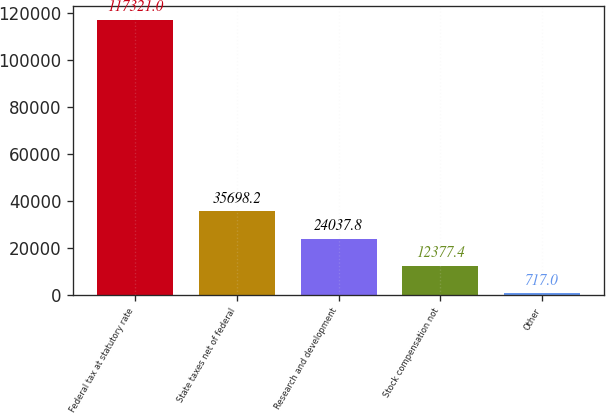Convert chart. <chart><loc_0><loc_0><loc_500><loc_500><bar_chart><fcel>Federal tax at statutory rate<fcel>State taxes net of federal<fcel>Research and development<fcel>Stock compensation not<fcel>Other<nl><fcel>117321<fcel>35698.2<fcel>24037.8<fcel>12377.4<fcel>717<nl></chart> 